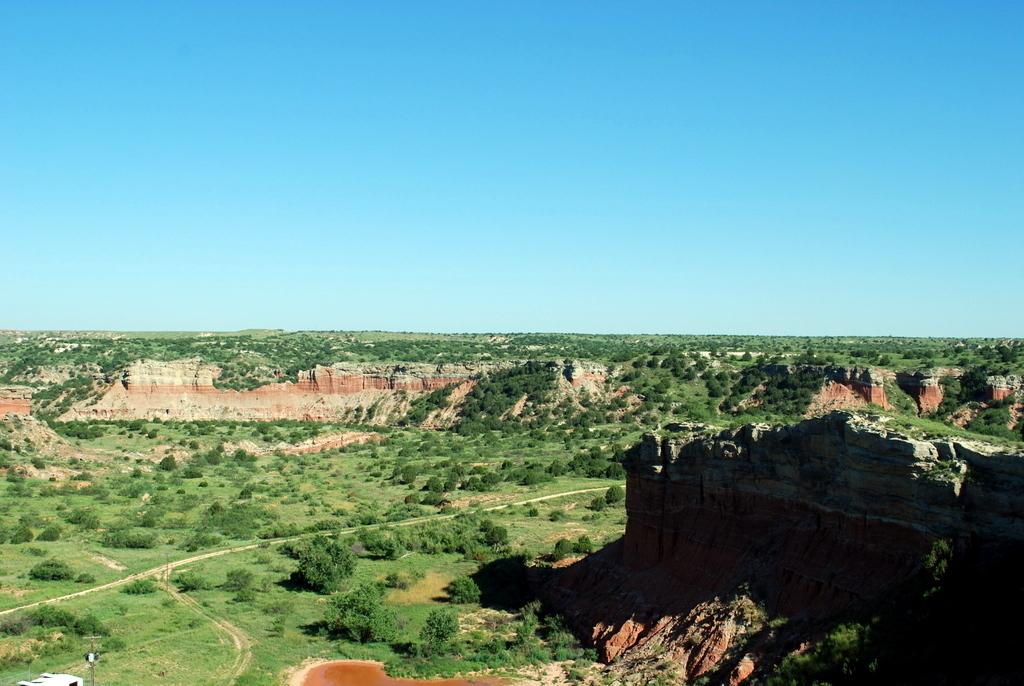What type of land is shown in the image? The image depicts a vast plateau land. What can be found on the plateau land? There are plants and grass on the plateau land. What is visible at the top of the image? The sky is visible at the top of the image. What color is the sky in the image? The sky is blue in color. Can you see a wren shaking a butter sculpture on the plateau land in the image? There is no wren or butter sculpture present in the image. 